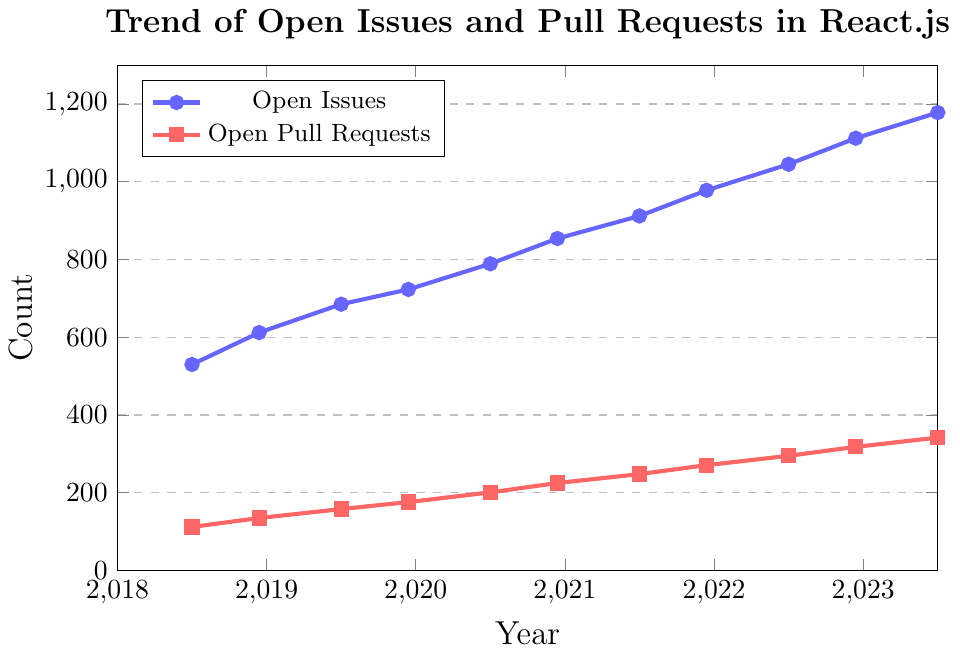What is the trend in the number of open issues from 2018 to 2023? The plot shows a continuous increase in the number of open issues over the years, starting from 530 in June 2018 and reaching 1178 by June 2023. This indicates a rising trend in open issues.
Answer: Increasing Compared to the number of open pull requests, how much greater is the number of open issues in June 2023? In June 2023, the number of open issues is 1178 while the number of open pull requests is 342. The difference between these two values is 1178 - 342 = 836.
Answer: 836 Is the increase in the number of open pull requests from June 2018 to June 2023 linear? Checking the data points for pull requests over time, we see that while the number steadily increases, the increments aren't uniform, showing varying increases over different time intervals. This suggests a generally increasing trend but not perfectly linear.
Answer: No Between which two consecutive time points is the increase in open issues the largest? By observing the increments from one time point to the next: June 2018-Dec 2018 (82), Dec 2018-June 2019 (73), June 2019-Dec 2019 (38), Dec 2019-June 2020 (66), June 2020-Dec 2020 (65), Dec 2020-June 2021 (58), June 2021-Dec 2021 (66), Dec 2021-June 2022 (67), June 2022-Dec 2022 (67), Dec 2022-June 2023 (66), the largest increase is between June 2018 and Dec 2018 (82).
Answer: June 2018 to Dec 2018 What is the average number of open pull requests in December from 2018 to 2022? The counts of open pull requests in Dec for the years 2018, 2019, 2020, 2021, and 2022 are 135, 176, 225, 271, and 318 respectively. The average is calculated as (135 + 176 + 225 + 271 + 318) / 5 = 225.
Answer: 225 Between which two time points does the number of open pull requests increase by exactly 47? By calculating the differences in pull requests between each interval: June 2018 - Dec 2018 (23), Dec 2018 - June 2019 (23), June 2019 - Dec 2019 (18), Dec 2019 - June 2020 (25), June 2020 - Dec 2020 (24), Dec 2020 - June 2021 (23), June 2021 - Dec 2021 (23), Dec 2021 - June 2022 (24), June 2022 - Dec 2022 (23), Dec 2022 - June 2023 (24), the interval Dec 2019 to June 2020 shows an increase by exactly 47.
Answer: Dec 2019 to June 2020 What is the visual color representation for open pull requests in the chart? The color used to represent open pull requests in the chart is red.
Answer: Red 